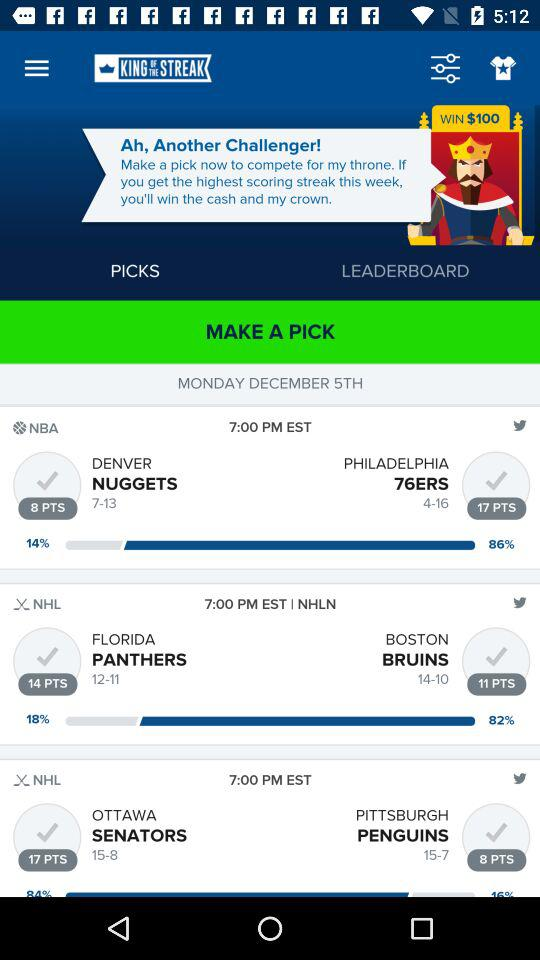What is the date of the matches? The date is Monday, December 5th. 